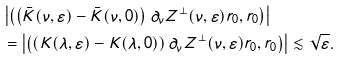<formula> <loc_0><loc_0><loc_500><loc_500>\ & \left | \left ( \left ( \bar { K } ( \nu , \varepsilon ) - \bar { K } ( \nu , 0 ) \right ) \partial _ { \nu } Z ^ { \perp } ( \nu , \varepsilon ) r _ { 0 } , r _ { 0 } \right ) \right | \\ & = \left | \left ( \left ( K ( \lambda , \varepsilon ) - K ( \lambda , 0 ) \right ) \partial _ { \nu } Z ^ { \perp } ( \nu , \varepsilon ) r _ { 0 } , r _ { 0 } \right ) \right | \lesssim \sqrt { \varepsilon } .</formula> 